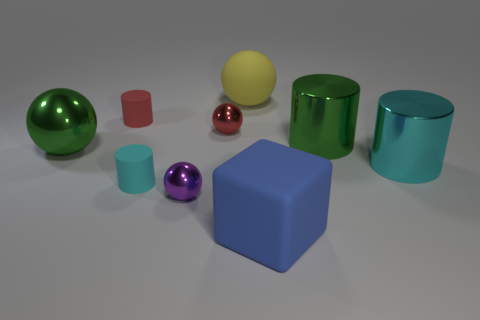How many brown things are either big blocks or big metallic cylinders?
Ensure brevity in your answer.  0. There is a large matte object behind the tiny red sphere; what shape is it?
Your response must be concise. Sphere. There is a rubber thing that is the same size as the rubber ball; what color is it?
Ensure brevity in your answer.  Blue. Does the large blue matte thing have the same shape as the green thing left of the tiny red metallic sphere?
Make the answer very short. No. What material is the red ball that is in front of the big matte object behind the object that is on the left side of the small red cylinder?
Make the answer very short. Metal. How many big objects are either rubber objects or purple objects?
Your answer should be very brief. 2. How many other things are there of the same size as the cyan matte object?
Your answer should be compact. 3. There is a cyan thing that is behind the cyan rubber object; is it the same shape as the blue object?
Provide a short and direct response. No. There is another big thing that is the same shape as the yellow matte object; what is its color?
Your answer should be very brief. Green. Is there anything else that is the same shape as the small red rubber thing?
Offer a very short reply. Yes. 